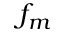<formula> <loc_0><loc_0><loc_500><loc_500>f _ { m }</formula> 